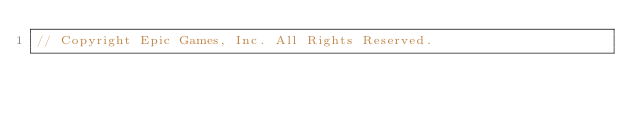Convert code to text. <code><loc_0><loc_0><loc_500><loc_500><_C++_>// Copyright Epic Games, Inc. All Rights Reserved.
</code> 